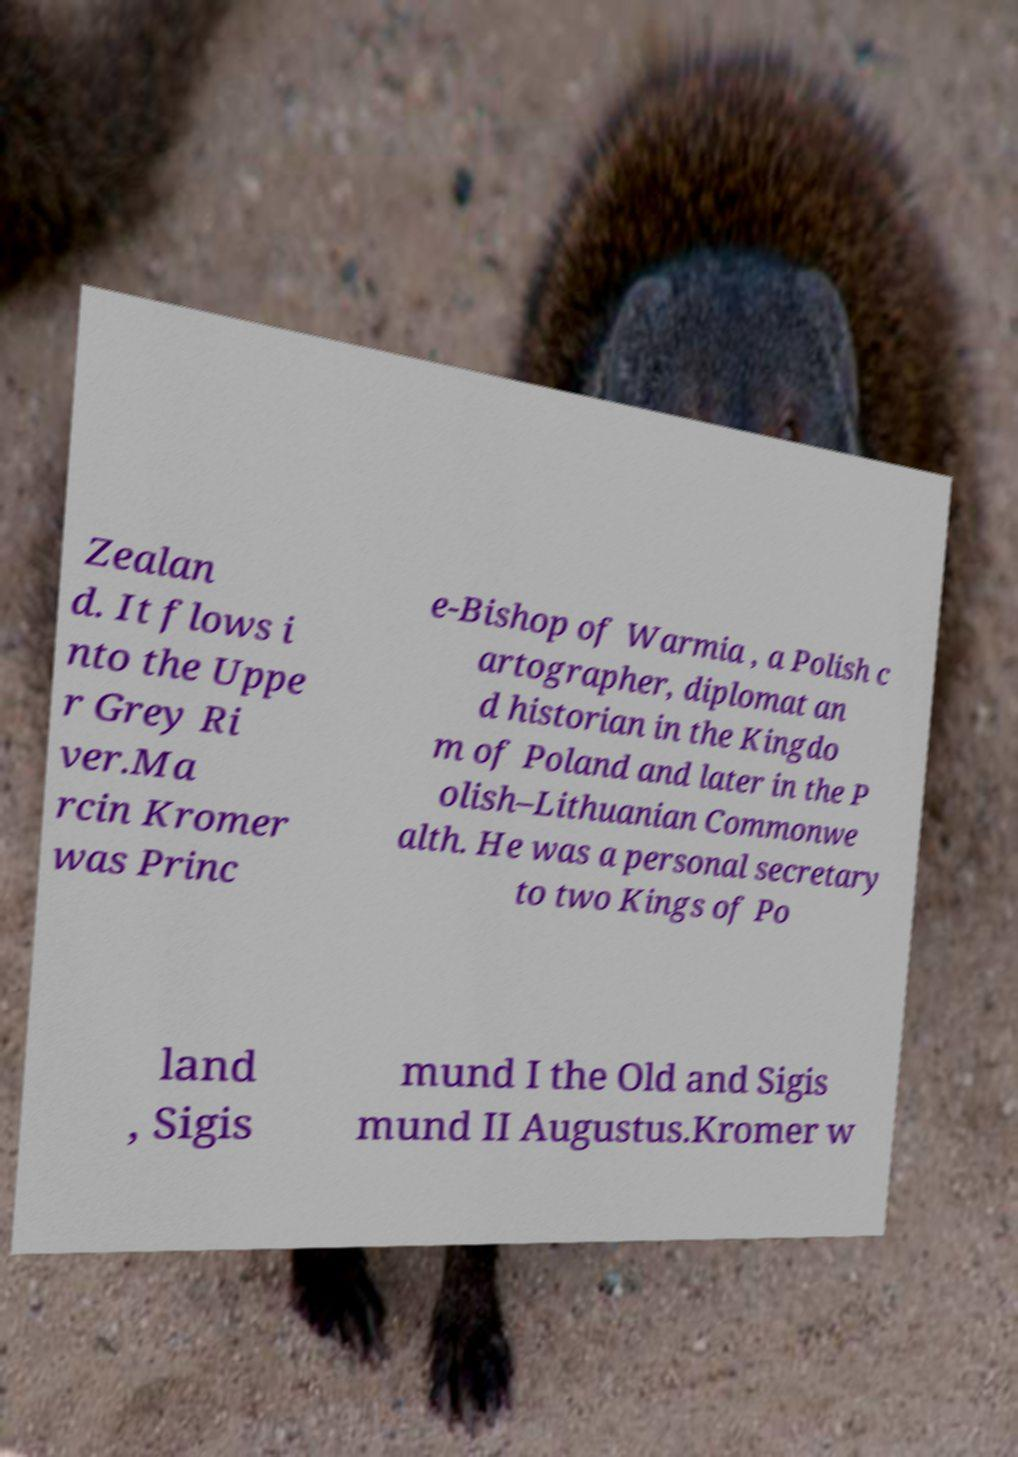Please identify and transcribe the text found in this image. Zealan d. It flows i nto the Uppe r Grey Ri ver.Ma rcin Kromer was Princ e-Bishop of Warmia , a Polish c artographer, diplomat an d historian in the Kingdo m of Poland and later in the P olish–Lithuanian Commonwe alth. He was a personal secretary to two Kings of Po land , Sigis mund I the Old and Sigis mund II Augustus.Kromer w 